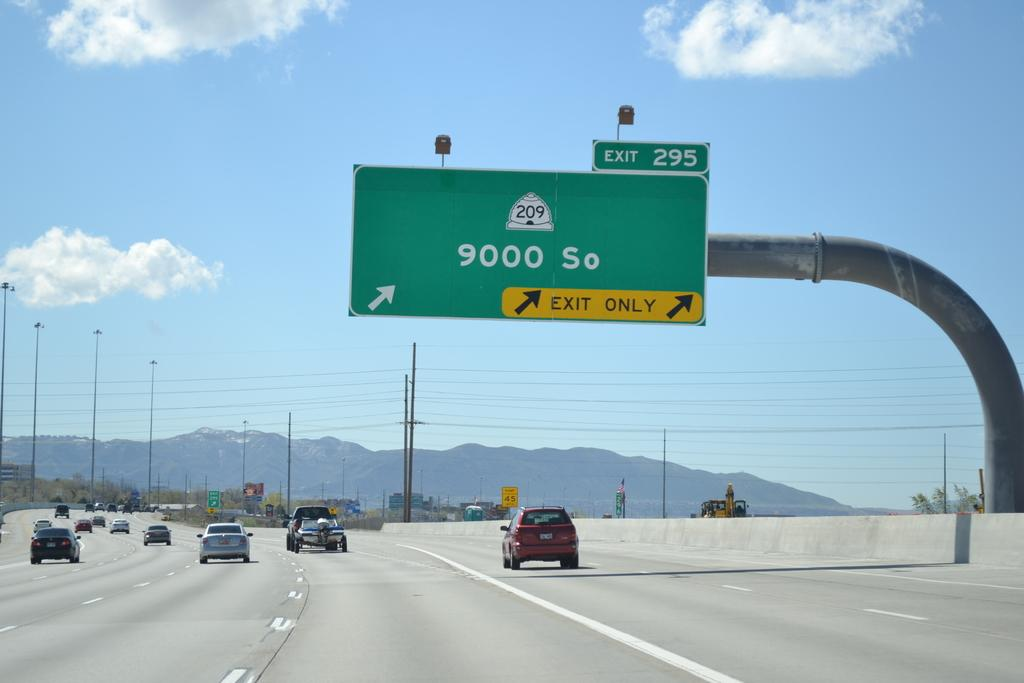Provide a one-sentence caption for the provided image. the number 9000 So that is on a sign. 